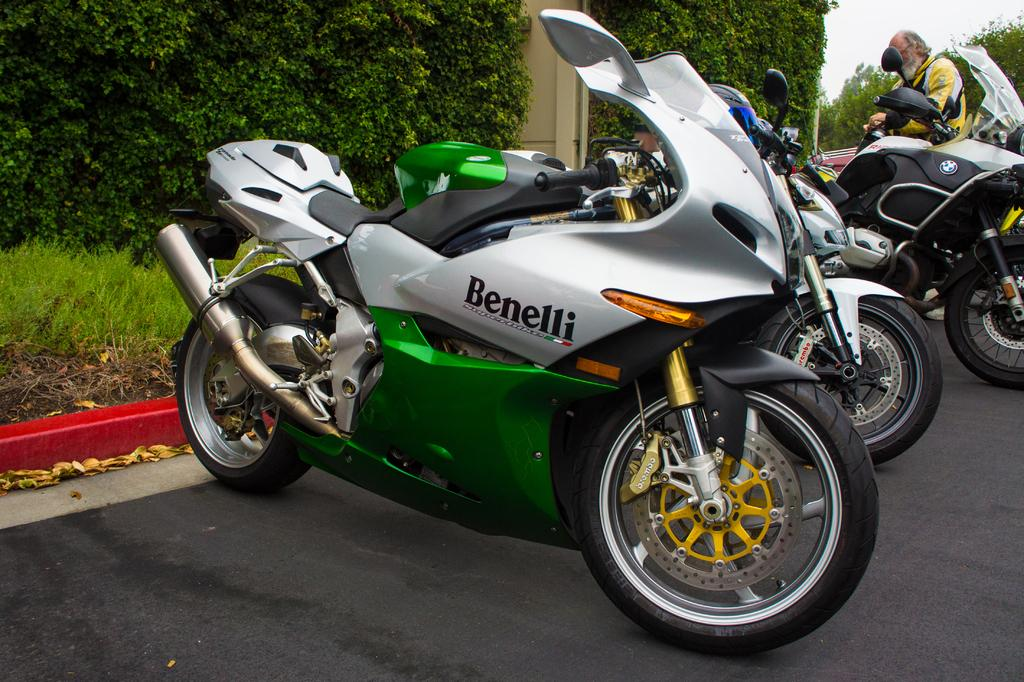What type of vehicles can be seen on the road in the image? There are bikes on the road in the image. Can you describe the person in the image? There is a person in the image. What type of natural environment is visible in the image? There is grass, plants, and trees visible in the image. What is visible in the background of the image? The sky is visible in the background of the image. What type of tent can be seen in the image? There is no tent present in the image. What need does the person in the image have? The image does not provide information about the person's needs. What role does the minister play in the image? There is no minister present in the image. 